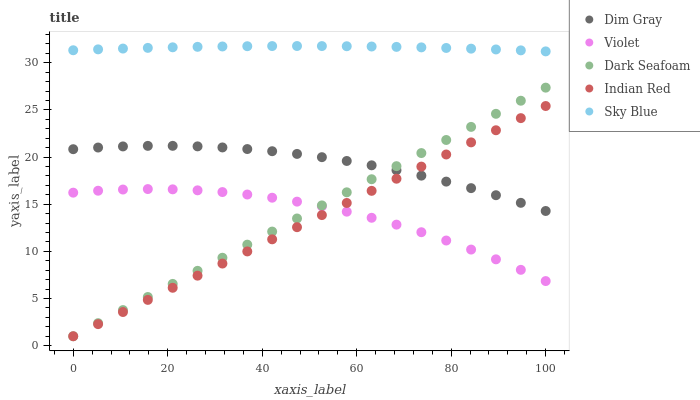Does Indian Red have the minimum area under the curve?
Answer yes or no. Yes. Does Sky Blue have the maximum area under the curve?
Answer yes or no. Yes. Does Dark Seafoam have the minimum area under the curve?
Answer yes or no. No. Does Dark Seafoam have the maximum area under the curve?
Answer yes or no. No. Is Indian Red the smoothest?
Answer yes or no. Yes. Is Violet the roughest?
Answer yes or no. Yes. Is Dark Seafoam the smoothest?
Answer yes or no. No. Is Dark Seafoam the roughest?
Answer yes or no. No. Does Dark Seafoam have the lowest value?
Answer yes or no. Yes. Does Dim Gray have the lowest value?
Answer yes or no. No. Does Sky Blue have the highest value?
Answer yes or no. Yes. Does Dark Seafoam have the highest value?
Answer yes or no. No. Is Violet less than Sky Blue?
Answer yes or no. Yes. Is Dim Gray greater than Violet?
Answer yes or no. Yes. Does Dark Seafoam intersect Dim Gray?
Answer yes or no. Yes. Is Dark Seafoam less than Dim Gray?
Answer yes or no. No. Is Dark Seafoam greater than Dim Gray?
Answer yes or no. No. Does Violet intersect Sky Blue?
Answer yes or no. No. 